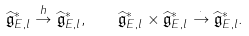Convert formula to latex. <formula><loc_0><loc_0><loc_500><loc_500>\widehat { \mathfrak { g } } _ { E , l } ^ { \ast } \stackrel { h } { \to } \widehat { \mathfrak { g } } _ { E , l } ^ { \ast } , \quad \widehat { \mathfrak { g } } _ { E , l } ^ { \ast } \times \widehat { \mathfrak { g } } _ { E , l } ^ { \ast } \stackrel { \cdot } { \to } \widehat { \mathfrak { g } } _ { E , l } ^ { \ast } .</formula> 